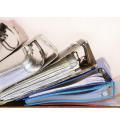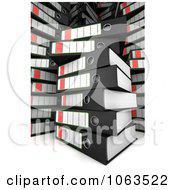The first image is the image on the left, the second image is the image on the right. For the images shown, is this caption "There is two stacks of binders in the center of the images." true? Answer yes or no. No. 